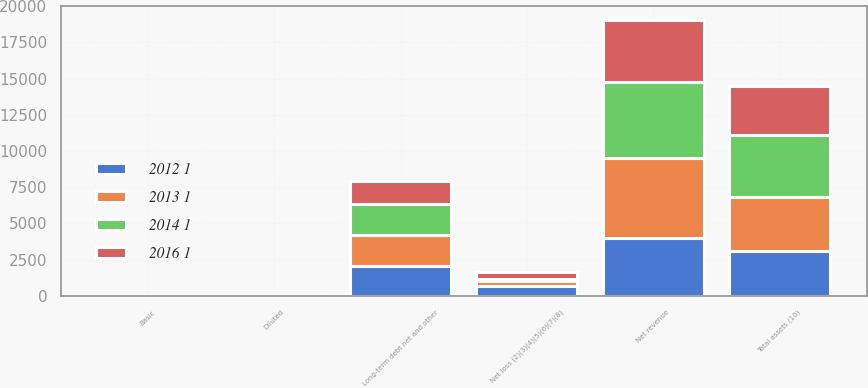<chart> <loc_0><loc_0><loc_500><loc_500><stacked_bar_chart><ecel><fcel>Net revenue<fcel>Net loss (2)(3)(4)(5)(6)(7)(8)<fcel>Basic<fcel>Diluted<fcel>Long-term debt net and other<fcel>Total assets (10)<nl><fcel>2016 1<fcel>4272<fcel>497<fcel>0.6<fcel>0.6<fcel>1559<fcel>3321<nl><fcel>2012 1<fcel>3991<fcel>660<fcel>0.84<fcel>0.84<fcel>2093<fcel>3084<nl><fcel>2013 1<fcel>5506<fcel>403<fcel>0.53<fcel>0.53<fcel>2110<fcel>3737<nl><fcel>2014 1<fcel>5299<fcel>83<fcel>0.11<fcel>0.11<fcel>2153<fcel>4315<nl></chart> 